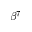Convert formula to latex. <formula><loc_0><loc_0><loc_500><loc_500>\beta ^ { 7 }</formula> 